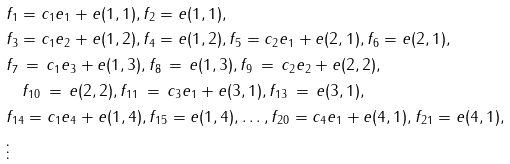Convert formula to latex. <formula><loc_0><loc_0><loc_500><loc_500>& f _ { 1 } = c _ { 1 } e _ { 1 } + e ( 1 , 1 ) , f _ { 2 } = e ( 1 , 1 ) , \\ & f _ { 3 } = c _ { 1 } e _ { 2 } + e ( 1 , 2 ) , f _ { 4 } = e ( 1 , 2 ) , f _ { 5 } = c _ { 2 } e _ { 1 } + e ( 2 , 1 ) , f _ { 6 } = e ( 2 , 1 ) , \\ & f _ { 7 } \, = \, c _ { 1 } e _ { 3 } + e ( 1 , 3 ) , f _ { 8 } \, = \, e ( 1 , 3 ) , f _ { 9 } \, = \, c _ { 2 } e _ { 2 } + e ( 2 , 2 ) , \\ & \quad f _ { 1 0 } \, = \, e ( 2 , 2 ) , f _ { 1 1 } \, = \, c _ { 3 } e _ { 1 } + e ( 3 , 1 ) , f _ { 1 3 } \, = \, e ( 3 , 1 ) , \\ & f _ { 1 4 } = c _ { 1 } e _ { 4 } + e ( 1 , 4 ) , f _ { 1 5 } = e ( 1 , 4 ) , \dots , f _ { 2 0 } = c _ { 4 } e _ { 1 } + e ( 4 , 1 ) , f _ { 2 1 } = e ( 4 , 1 ) , \\ & \vdots</formula> 